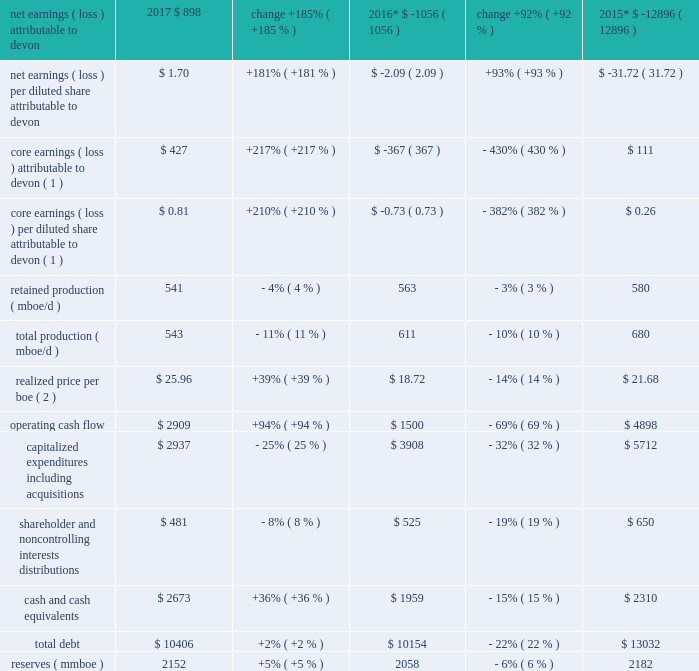Item 7 .
Management 2019s discussion and analysis of financial condition and results of operations introduction the following discussion and analysis presents management 2019s perspective of our business , financial condition and overall performance .
This information is intended to provide investors with an understanding of our past performance , current financial condition and outlook for the future and should be read in conjunction with 201citem 8 .
Financial statements and supplementary data 201d of this report .
Overview of 2017 results during 2017 , we generated solid operating results with our strategy of operating in north america 2019s best resource plays , delivering superior execution , continuing disciplined capital allocation and maintaining a high degree of financial strength .
Led by our development in the stack and delaware basin , we continued to improve our 90-day initial production rates .
With investments in proprietary data tools , predictive analytics and artificial intelligence , we are delivering industry-leading , initial-rate well productivity performance and improving the performance of our established wells .
Compared to 2016 , commodity prices increased significantly and were the primary driver for improvements in devon 2019s earnings and cash flow during 2017 .
We exited 2017 with liquidity comprised of $ 2.7 billion of cash and $ 2.9 billion of available credit under our senior credit facility .
We have no significant debt maturities until 2021 .
We further enhanced our financial strength by completing approximately $ 415 million of our announced $ 1 billion asset divestiture program in 2017 .
We anticipate closing the remaining divestitures in 2018 .
In 2018 and beyond , we have the financial capacity to further accelerate investment across our best-in-class u.s .
Resource plays .
We are increasing drilling activity and will continue to shift our production mix to high-margin products .
We will continue our premier technical work to drive capital allocation and efficiency and industry- leading well productivity results .
We will continue to maximize the value of our base production by sustaining the operational efficiencies we have achieved .
Finally , we will continue to manage activity levels within our cash flows .
We expect this disciplined approach will position us to deliver capital-efficient , cash-flow expansion over the next two years .
Key measures of our financial performance in 2017 are summarized in the table .
Increased commodity prices as well as continued focus on our production expenses improved our 2017 financial performance as compared to 2016 , as seen in the table below .
More details for these metrics are found within the 201cresults of operations 2013 2017 vs .
2016 201d , below. .

What is the ratio of operating cash flow to total debt in 2017? 
Rationale: this is how many years it would take to repay the debt at existing cash flow with no new debt .
Computations: (10406 / 2909)
Answer: 3.57717. 